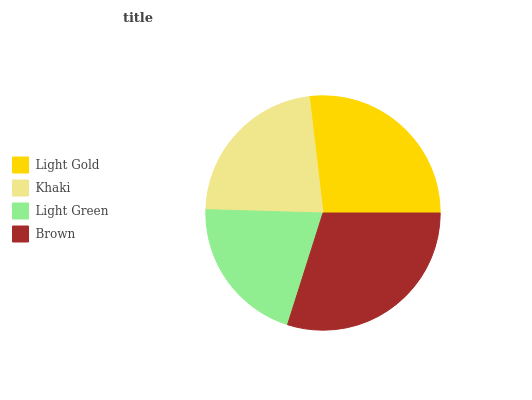Is Light Green the minimum?
Answer yes or no. Yes. Is Brown the maximum?
Answer yes or no. Yes. Is Khaki the minimum?
Answer yes or no. No. Is Khaki the maximum?
Answer yes or no. No. Is Light Gold greater than Khaki?
Answer yes or no. Yes. Is Khaki less than Light Gold?
Answer yes or no. Yes. Is Khaki greater than Light Gold?
Answer yes or no. No. Is Light Gold less than Khaki?
Answer yes or no. No. Is Light Gold the high median?
Answer yes or no. Yes. Is Khaki the low median?
Answer yes or no. Yes. Is Light Green the high median?
Answer yes or no. No. Is Brown the low median?
Answer yes or no. No. 